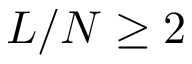<formula> <loc_0><loc_0><loc_500><loc_500>L / N \geq 2</formula> 